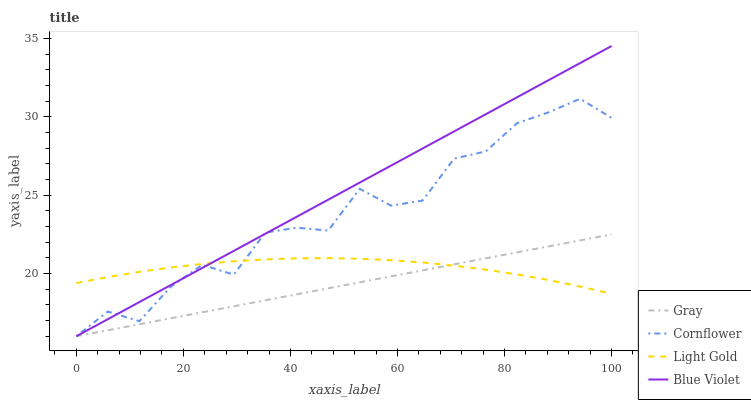Does Gray have the minimum area under the curve?
Answer yes or no. Yes. Does Blue Violet have the maximum area under the curve?
Answer yes or no. Yes. Does Light Gold have the minimum area under the curve?
Answer yes or no. No. Does Light Gold have the maximum area under the curve?
Answer yes or no. No. Is Gray the smoothest?
Answer yes or no. Yes. Is Cornflower the roughest?
Answer yes or no. Yes. Is Light Gold the smoothest?
Answer yes or no. No. Is Light Gold the roughest?
Answer yes or no. No. Does Gray have the lowest value?
Answer yes or no. Yes. Does Light Gold have the lowest value?
Answer yes or no. No. Does Blue Violet have the highest value?
Answer yes or no. Yes. Does Light Gold have the highest value?
Answer yes or no. No. Does Gray intersect Light Gold?
Answer yes or no. Yes. Is Gray less than Light Gold?
Answer yes or no. No. Is Gray greater than Light Gold?
Answer yes or no. No. 